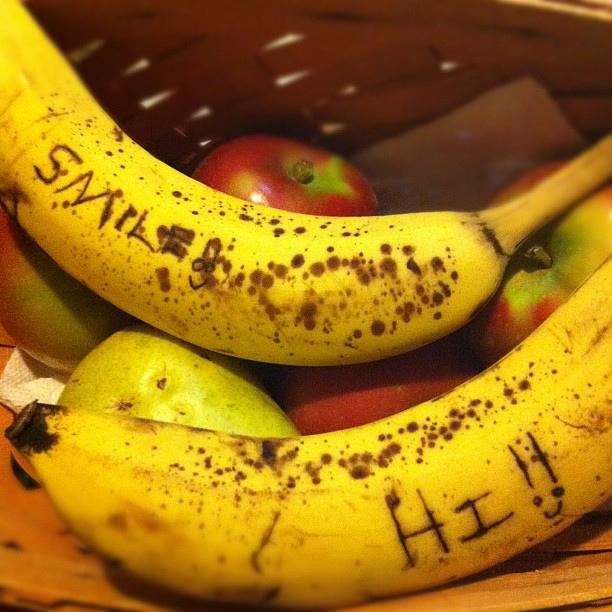What animal do the spots on the banana most resemble?

Choices:
A) bear
B) hippo
C) giraffe
D) lion giraffe 